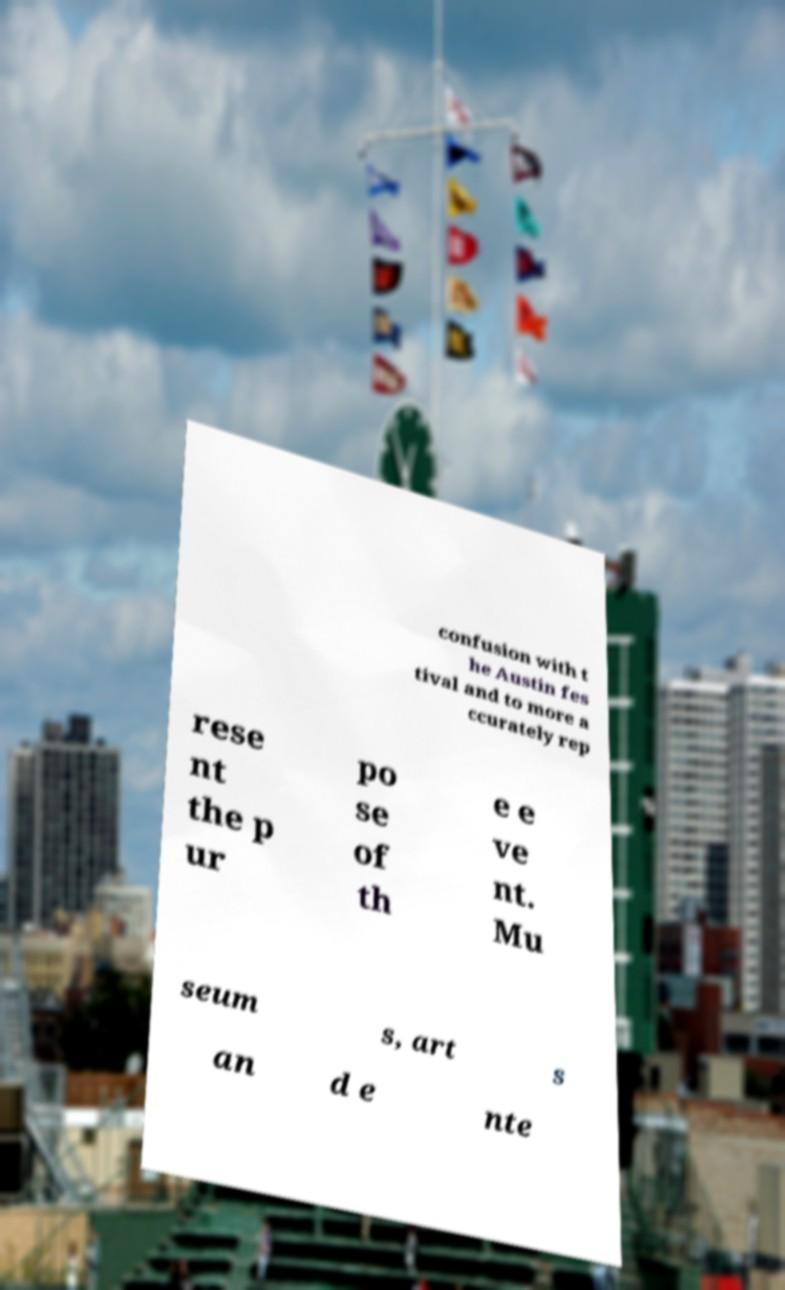Can you read and provide the text displayed in the image?This photo seems to have some interesting text. Can you extract and type it out for me? confusion with t he Austin fes tival and to more a ccurately rep rese nt the p ur po se of th e e ve nt. Mu seum s, art s an d e nte 